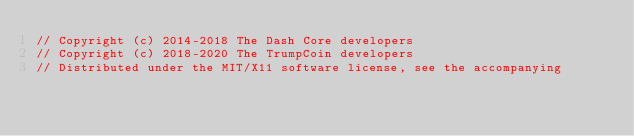<code> <loc_0><loc_0><loc_500><loc_500><_C++_>// Copyright (c) 2014-2018 The Dash Core developers
// Copyright (c) 2018-2020 The TrumpCoin developers
// Distributed under the MIT/X11 software license, see the accompanying</code> 